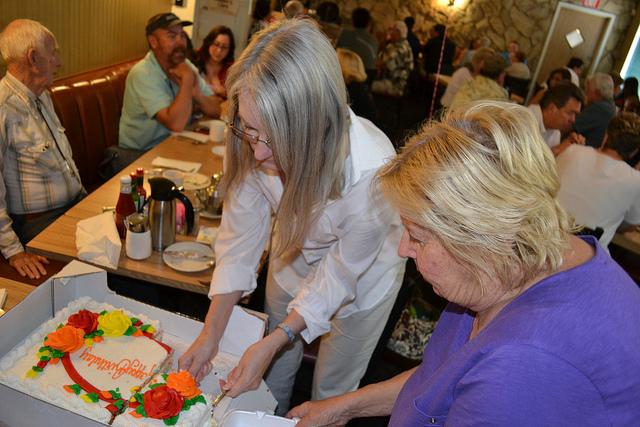Do the people look happy?
Give a very brief answer. No. Is the woman giving the teddy bear to the girl?
Concise answer only. No. What occasion are they celebrating?
Be succinct. Birthday. What color is the writing on the cake?
Be succinct. Orange. 